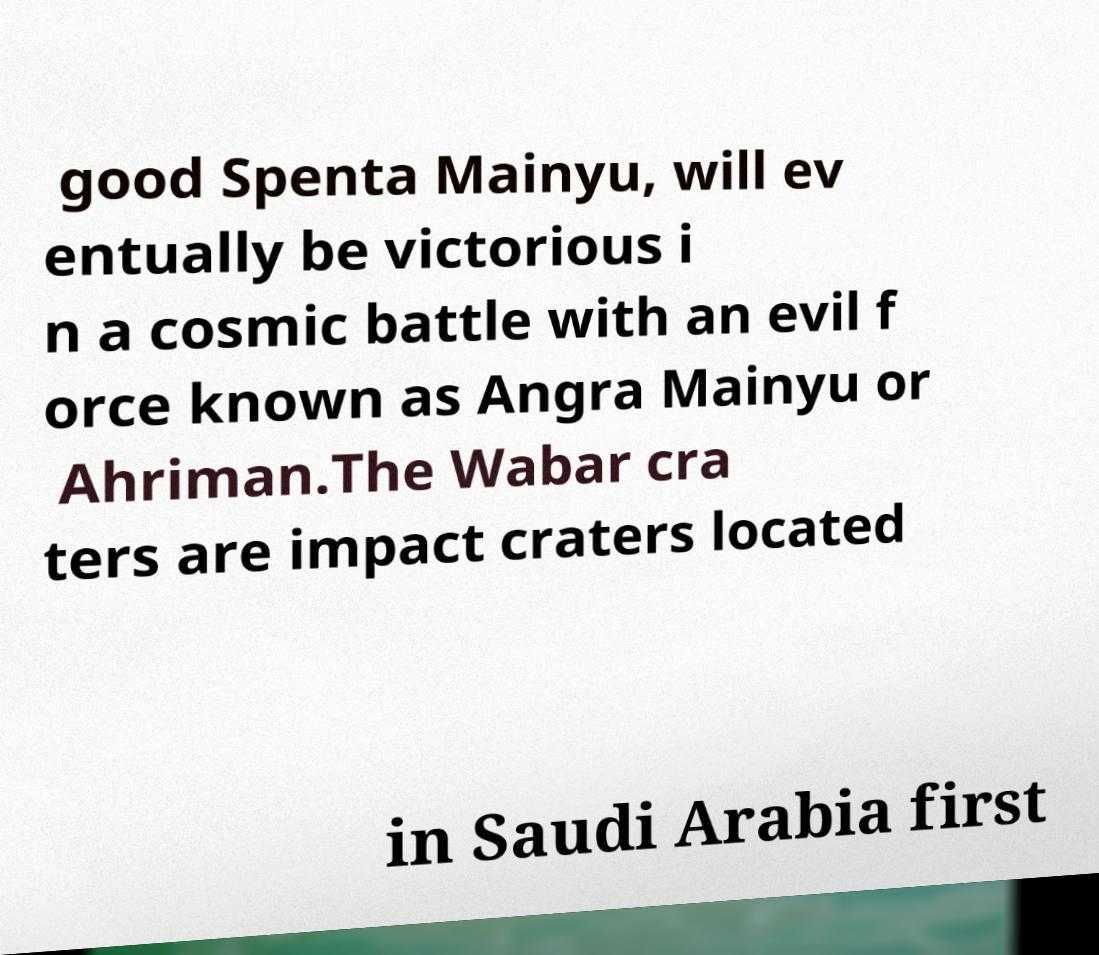Please identify and transcribe the text found in this image. good Spenta Mainyu, will ev entually be victorious i n a cosmic battle with an evil f orce known as Angra Mainyu or Ahriman.The Wabar cra ters are impact craters located in Saudi Arabia first 